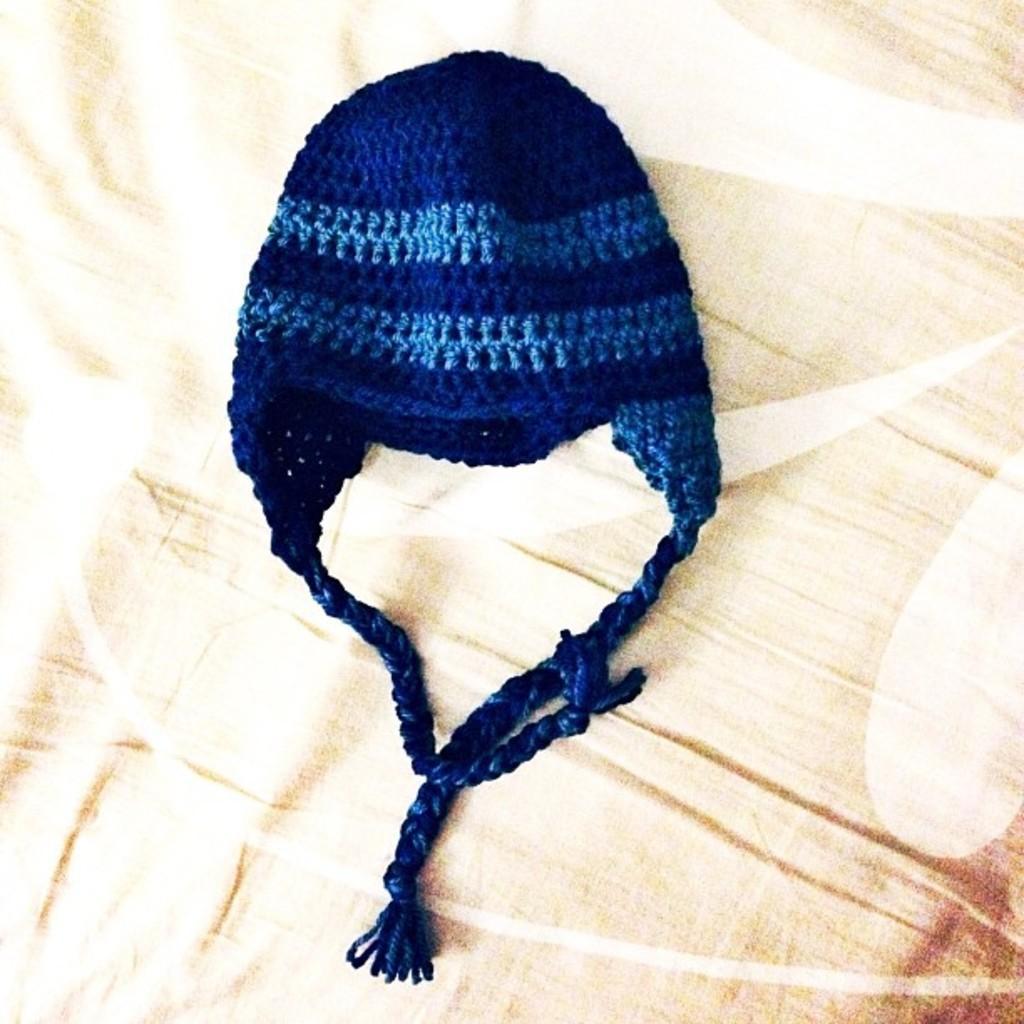In one or two sentences, can you explain what this image depicts? In this image there is a knit cap, at the background of the image there is a cloth truncated. 